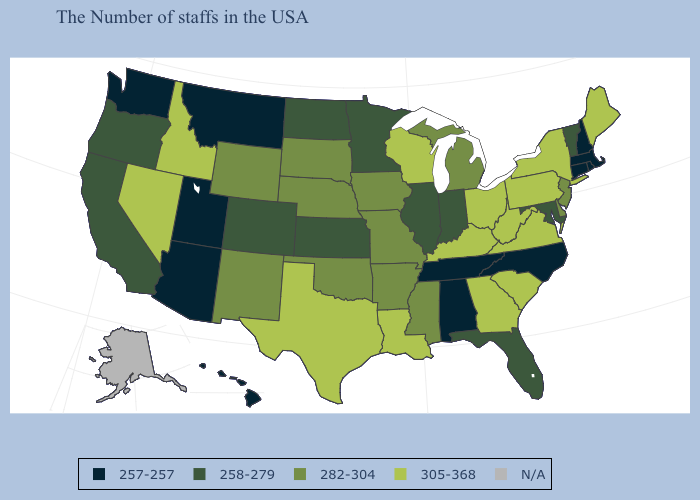What is the value of California?
Be succinct. 258-279. Name the states that have a value in the range N/A?
Write a very short answer. Alaska. What is the value of Michigan?
Write a very short answer. 282-304. Does Kansas have the lowest value in the USA?
Quick response, please. No. Name the states that have a value in the range 305-368?
Quick response, please. Maine, New York, Pennsylvania, Virginia, South Carolina, West Virginia, Ohio, Georgia, Kentucky, Wisconsin, Louisiana, Texas, Idaho, Nevada. What is the value of Delaware?
Keep it brief. 282-304. Which states have the lowest value in the USA?
Quick response, please. Massachusetts, Rhode Island, New Hampshire, Connecticut, North Carolina, Alabama, Tennessee, Utah, Montana, Arizona, Washington, Hawaii. Name the states that have a value in the range 258-279?
Keep it brief. Vermont, Maryland, Florida, Indiana, Illinois, Minnesota, Kansas, North Dakota, Colorado, California, Oregon. Does Montana have the lowest value in the USA?
Keep it brief. Yes. Is the legend a continuous bar?
Concise answer only. No. What is the highest value in the MidWest ?
Concise answer only. 305-368. Name the states that have a value in the range 305-368?
Be succinct. Maine, New York, Pennsylvania, Virginia, South Carolina, West Virginia, Ohio, Georgia, Kentucky, Wisconsin, Louisiana, Texas, Idaho, Nevada. 